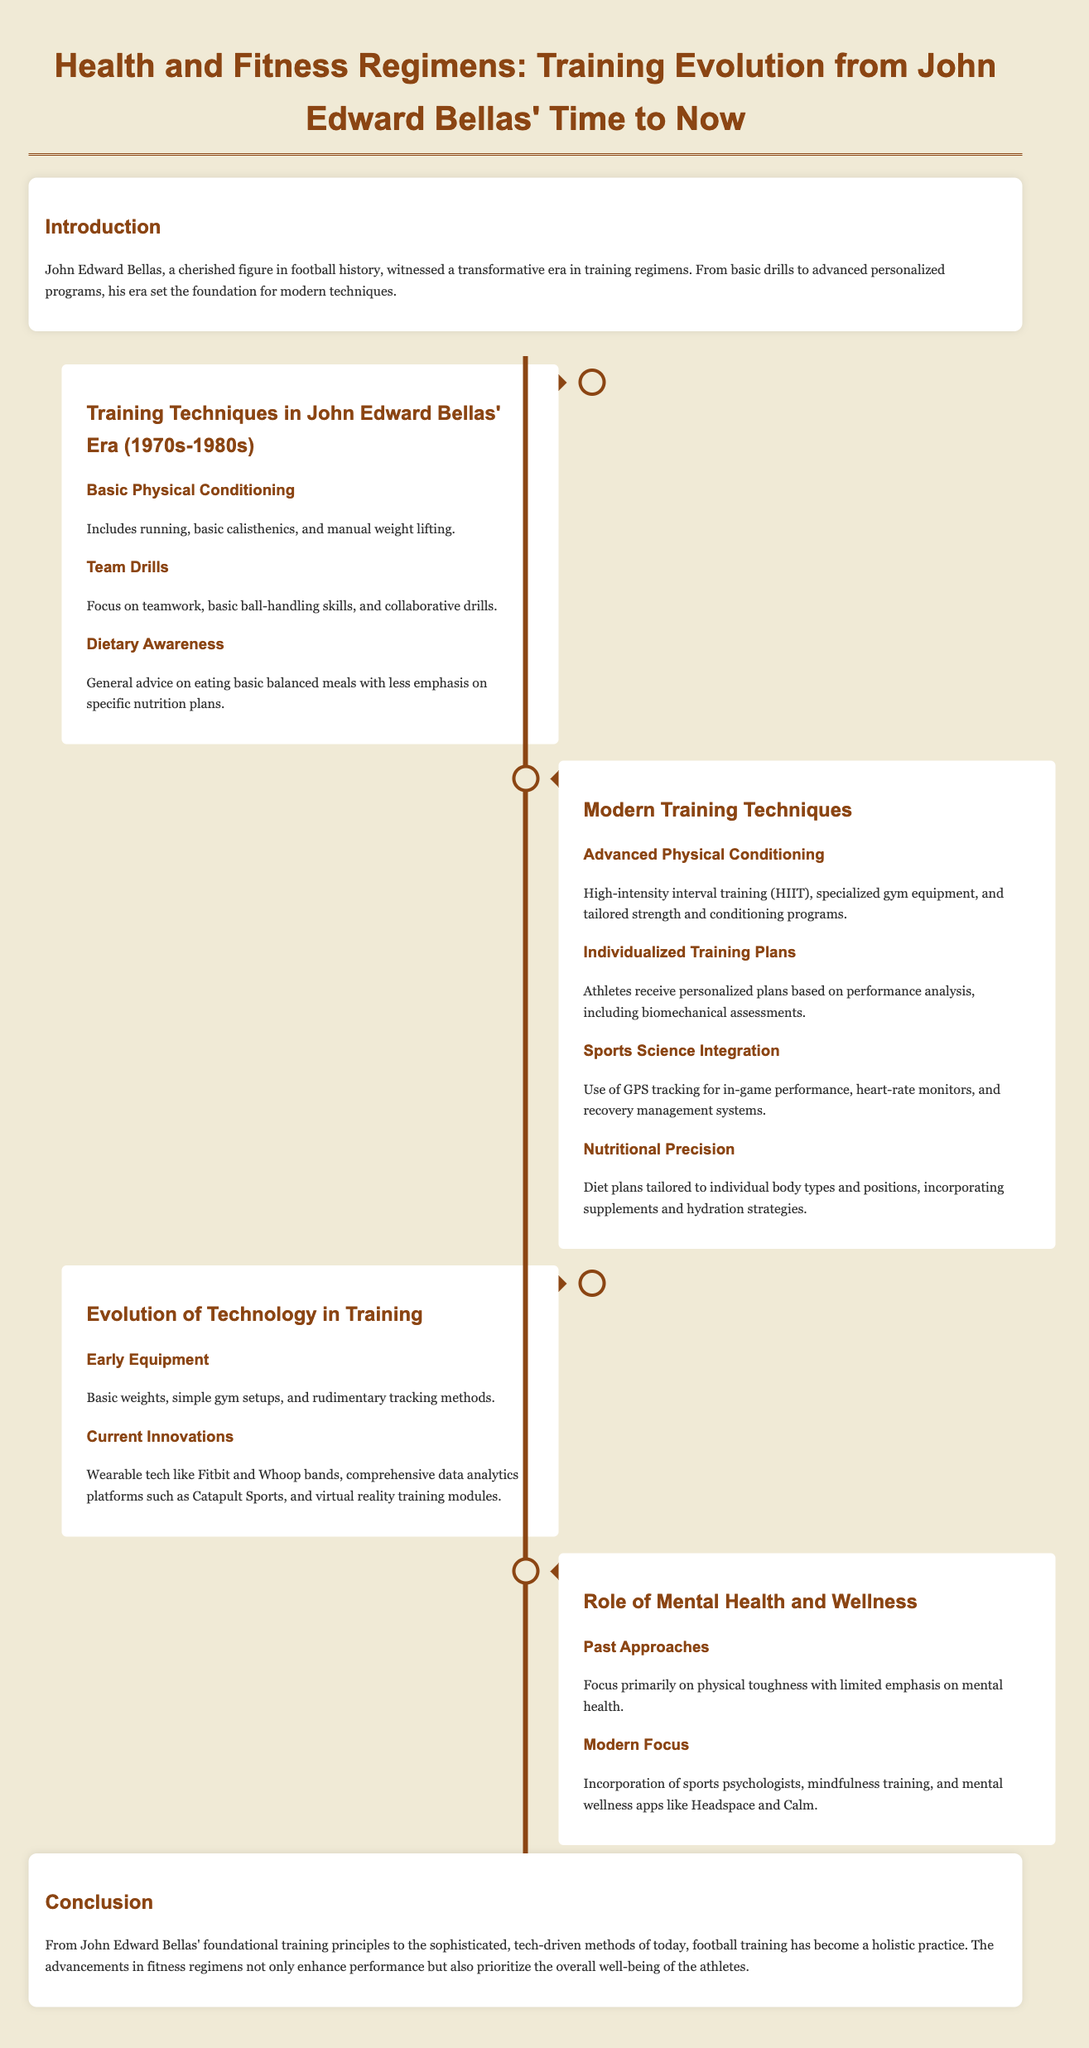what decade did John Edward Bellas' training techniques belong to? The document states that John Edward Bellas' training techniques were from the 1970s-1980s.
Answer: 1970s-1980s what type of advanced training is mentioned in modern techniques? The document mentions high-intensity interval training (HIIT) as part of advanced training techniques.
Answer: HIIT what was a past approach to mental health in training? The document indicates that past approaches focused primarily on physical toughness with limited emphasis on mental health.
Answer: Limited emphasis on mental health how is nutritional precision characterized in modern training? The document describes nutritional precision as diet plans tailored to individual body types and positions.
Answer: Tailored to individual body types what is one piece of early equipment utilized in training during Bellas' time? The document mentions basic weights as one piece of early equipment used in training.
Answer: Basic weights what type of training plans do athletes receive in modern training? The document states that athletes receive personalized plans based on performance analysis.
Answer: Personalized plans which technology is used for athlete performance tracking in modern techniques? GPS tracking is highlighted in the document as a technology used for in-game performance.
Answer: GPS tracking what type of training has been incorporated in modern approaches for mental health? Incorporation of sports psychologists is mentioned as a modern approach for mental health training.
Answer: Sports psychologists 